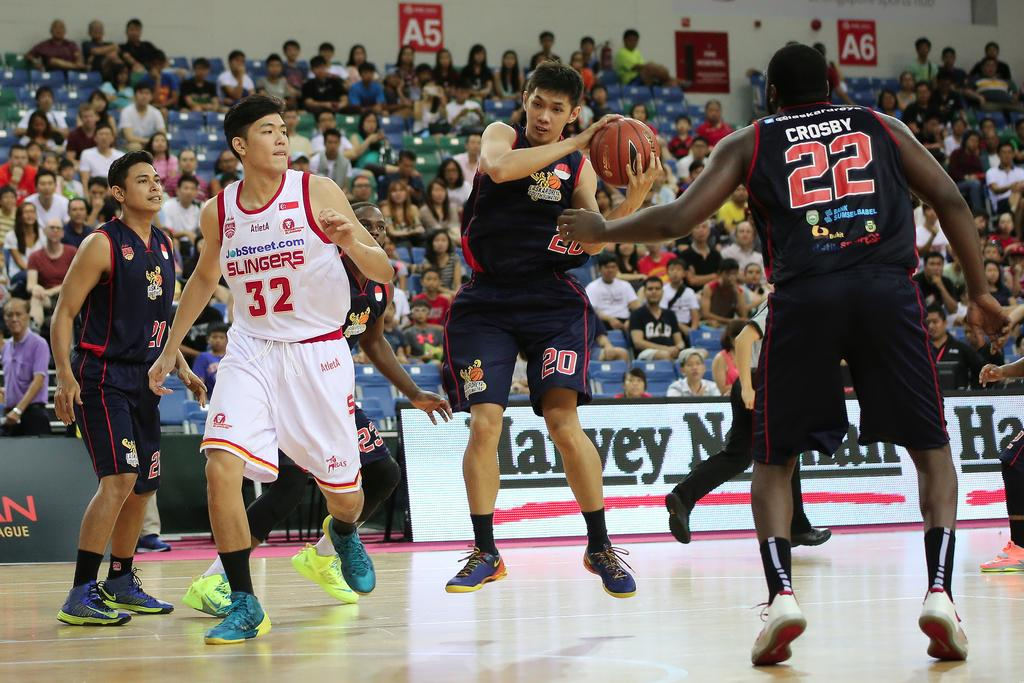<image>
Provide a brief description of the given image. Player number 22 tries to assist the player with the basketball. 